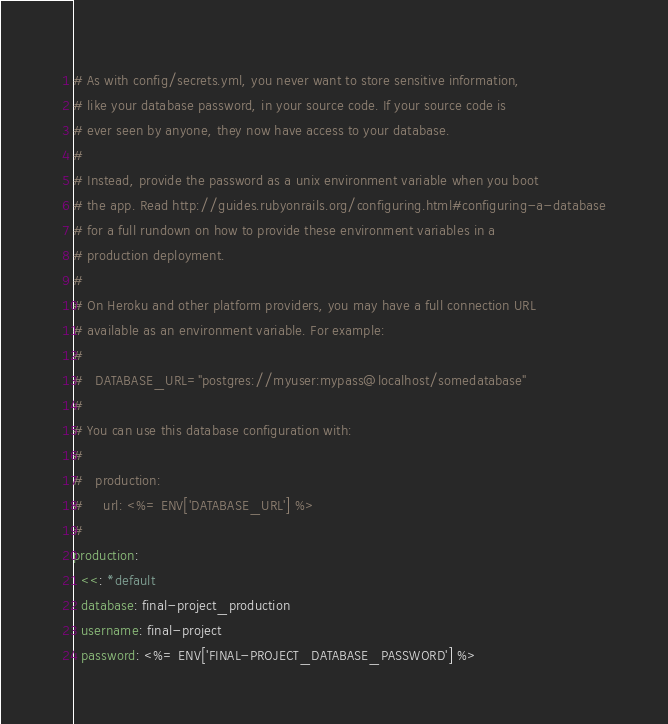Convert code to text. <code><loc_0><loc_0><loc_500><loc_500><_YAML_>
# As with config/secrets.yml, you never want to store sensitive information,
# like your database password, in your source code. If your source code is
# ever seen by anyone, they now have access to your database.
#
# Instead, provide the password as a unix environment variable when you boot
# the app. Read http://guides.rubyonrails.org/configuring.html#configuring-a-database
# for a full rundown on how to provide these environment variables in a
# production deployment.
#
# On Heroku and other platform providers, you may have a full connection URL
# available as an environment variable. For example:
#
#   DATABASE_URL="postgres://myuser:mypass@localhost/somedatabase"
#
# You can use this database configuration with:
#
#   production:
#     url: <%= ENV['DATABASE_URL'] %>
#
production:
  <<: *default
  database: final-project_production
  username: final-project
  password: <%= ENV['FINAL-PROJECT_DATABASE_PASSWORD'] %>
</code> 